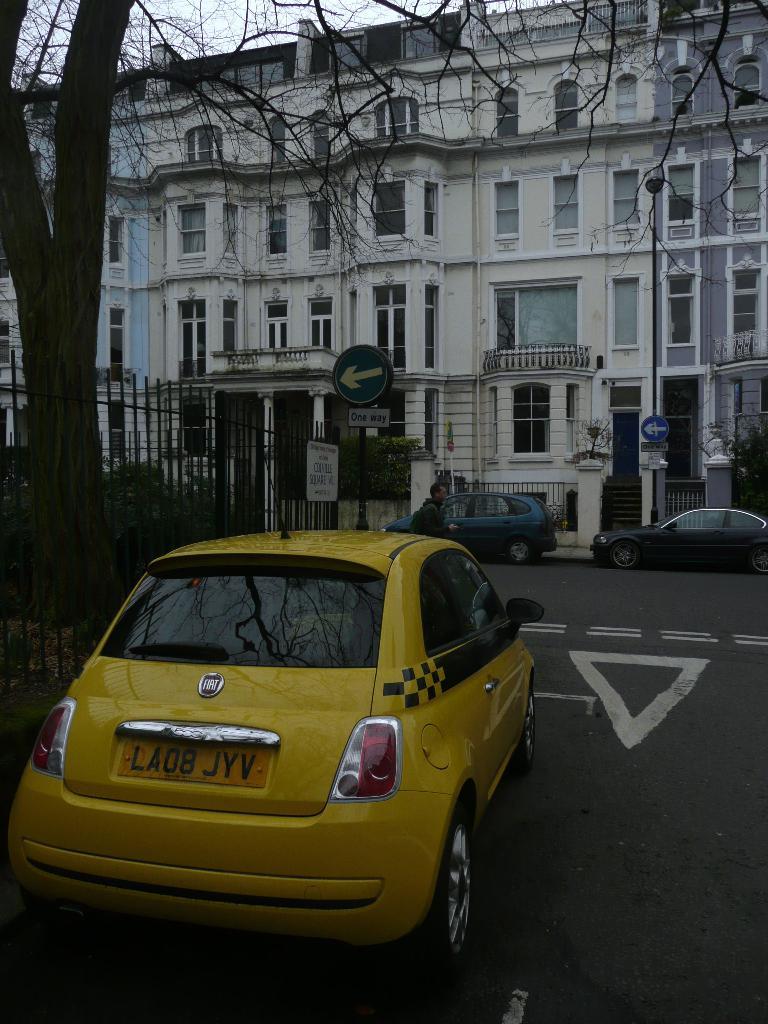What is the license plate number for this car?
Keep it short and to the point. La08 jyv. 